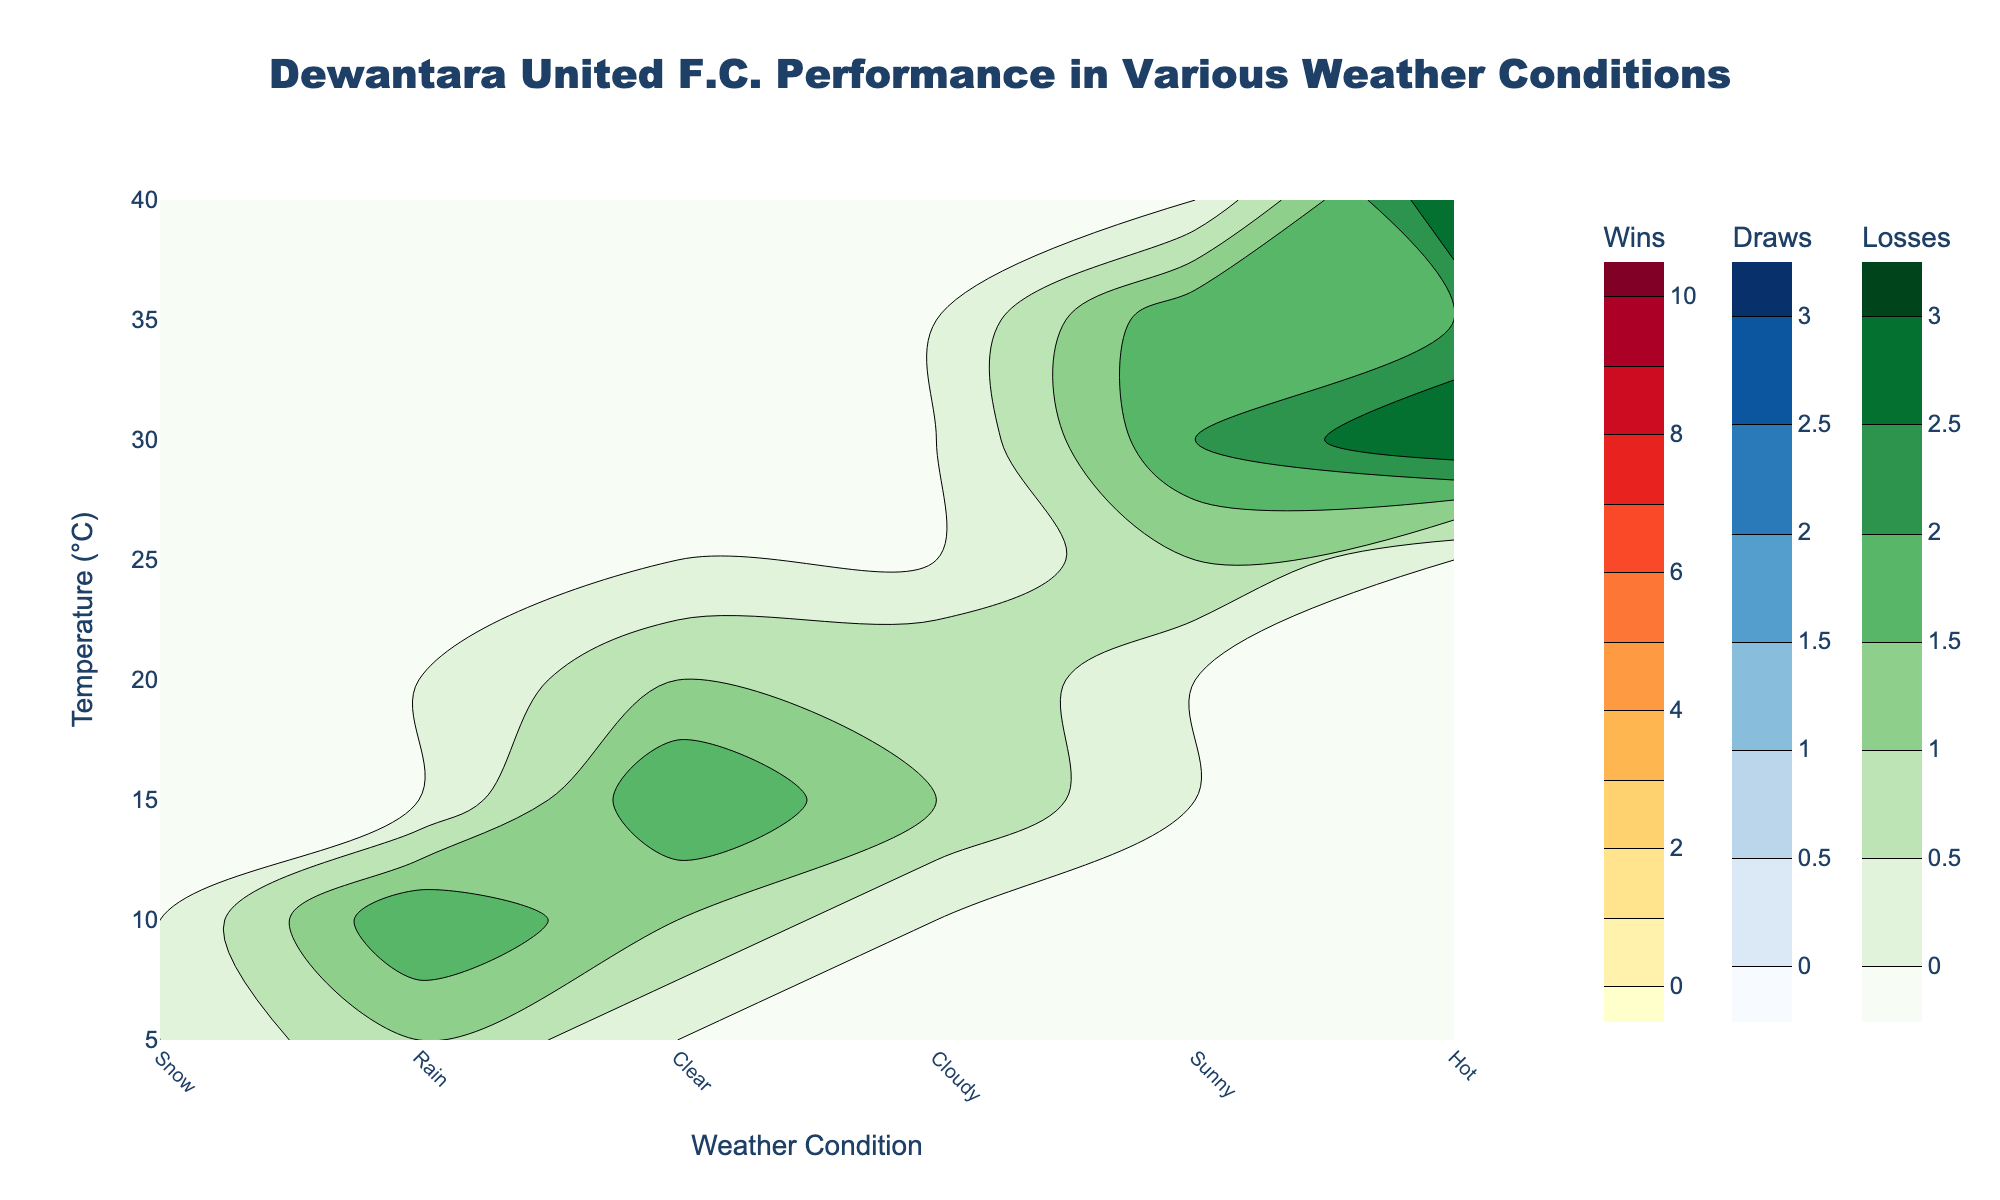What is the title of the figure? The title can be found at the top of the figure. It usually summarizes what the plot represents.
Answer: Dewantara United F.C. Performance in Various Weather Conditions Which weather condition appears most frequently in the plot? The frequency of weather conditions can be visually assessed by seeing how often different weather labels appear across the x-axis.
Answer: Clear How many win contours are present in the plot? To count the number of win contours, look for contour lines within the ‘Wins’ color scale area (YlOrRd). Each contour represents a level of win density.
Answer: 10 Which temperature has the highest number of wins in Sunny weather? Identify the 'Sunny' condition along the x-axis and scan vertically to locate the highest win value within the contour area.
Answer: 25°C At what temperature and weather condition do the most draws occur? Locate the highest contour level within the Blue (draw) contour plot and determine its corresponding temperature and weather condition along the axes.
Answer: 30°C, Sunny In which weather condition do the highest number of losses occur at 40°C? Find the 40°C mark on the y-axis and look across the losses (Greens) contour plot to find the highest contour level.
Answer: Hot Is the number of draws more sensitive to weather or temperature changes? Observe how tightly packed the draw contours (Blues) are in relation to changes in weather versus temperature. Tighter packing indicates higher sensitivity.
Answer: Weather Compare the win contours between Rain and Cloudy conditions. Which has a more favorable win performance at 15°C? Look at the win contours (YlOrRd) at 15°C for both Rain and Cloudy conditions and check which has higher win values.
Answer: Cloudy What temperature range shows a dramatic increase in wins from one weather condition to another? Look for steep changes in the win (YlOrRd) contour lines where temperature changes, noting the weather conditions involved.
Answer: Between 10°C to 15°C from Rain to Clear Are there any temperatures where Dewantara United F.C. has not lost any matches regardless of the weather condition? Check across different temperature levels in the losses (Greens) contour plot for any absence of contour lines.
Answer: 25°C 